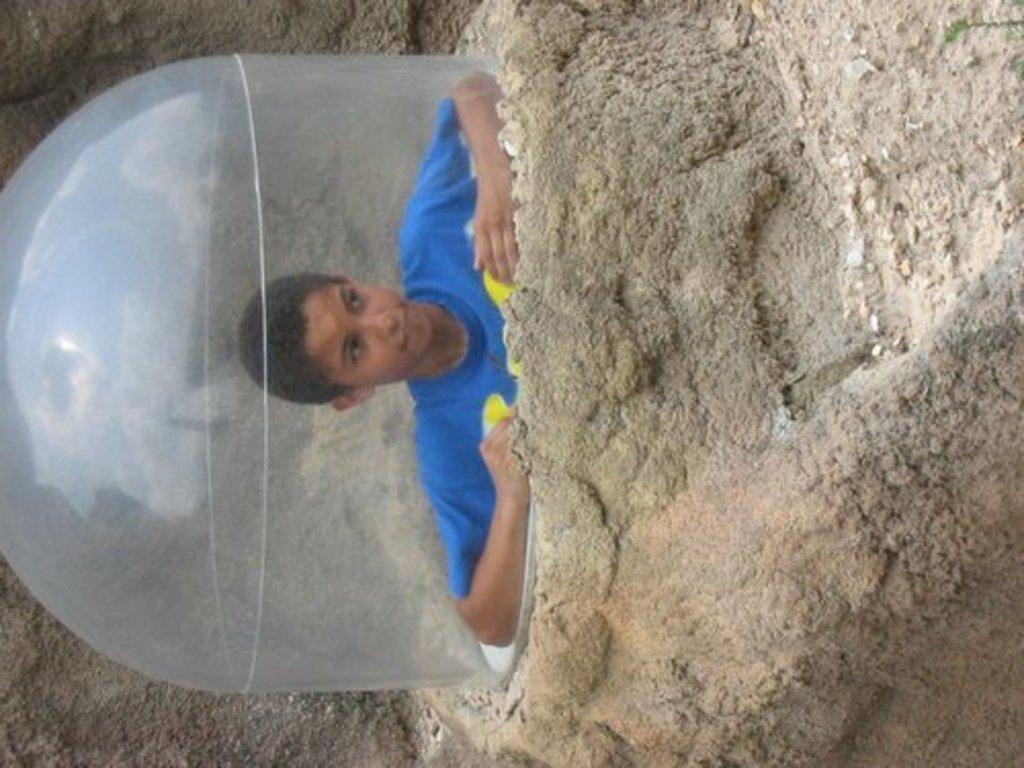Who is the main subject in the image? There is a boy in the image. What is the boy wearing? The boy is wearing a blue t-shirt. Where is the boy sitting in the image? The boy is sitting under a rock mountain. What other object can be seen in the image? There is a transparent balloon visible in the image. What is the main feature in the foreground of the image? There is a rock mountain in the front of the image. What type of impulse can be seen affecting the rock mountain in the image? There is no impulse affecting the rock mountain in the image; it is a stationary object. What is the texture of the boy's t-shirt in the image? The texture of the boy's t-shirt cannot be determined from the image alone. 